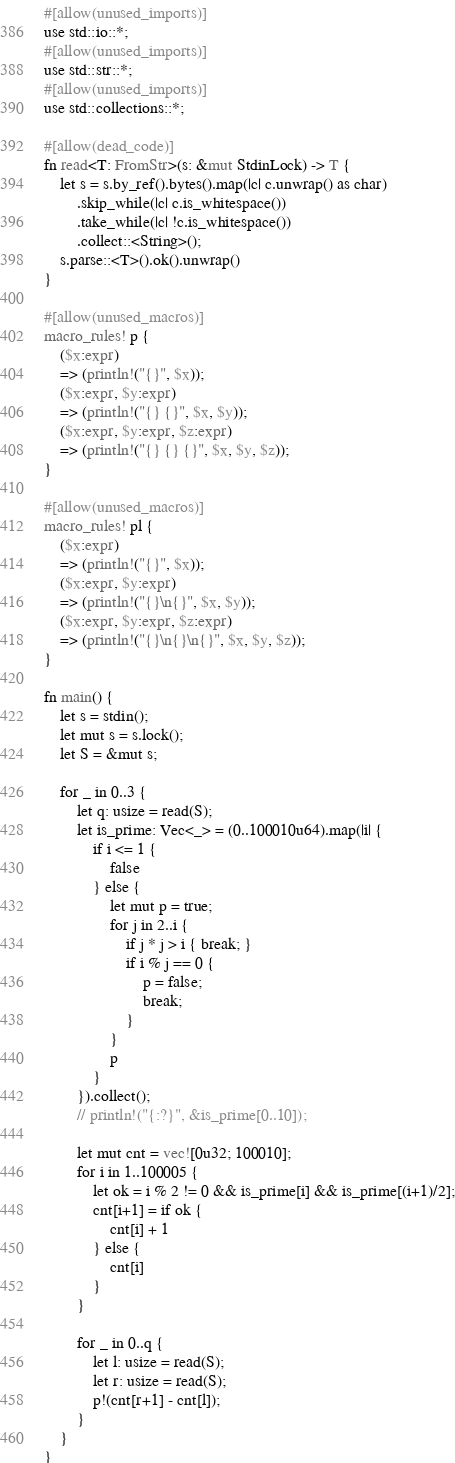<code> <loc_0><loc_0><loc_500><loc_500><_Rust_>#[allow(unused_imports)]
use std::io::*;
#[allow(unused_imports)]
use std::str::*;
#[allow(unused_imports)]
use std::collections::*;

#[allow(dead_code)]
fn read<T: FromStr>(s: &mut StdinLock) -> T {
    let s = s.by_ref().bytes().map(|c| c.unwrap() as char)
        .skip_while(|c| c.is_whitespace())
        .take_while(|c| !c.is_whitespace())
        .collect::<String>();
    s.parse::<T>().ok().unwrap()
}

#[allow(unused_macros)]
macro_rules! p {
    ($x:expr) 
    => (println!("{}", $x));
    ($x:expr, $y:expr)
    => (println!("{} {}", $x, $y));
    ($x:expr, $y:expr, $z:expr) 
    => (println!("{} {} {}", $x, $y, $z));
}

#[allow(unused_macros)]
macro_rules! pl {
    ($x:expr) 
    => (println!("{}", $x));
    ($x:expr, $y:expr)
    => (println!("{}\n{}", $x, $y));
    ($x:expr, $y:expr, $z:expr) 
    => (println!("{}\n{}\n{}", $x, $y, $z));
}

fn main() {
    let s = stdin();
    let mut s = s.lock();
    let S = &mut s;

    for _ in 0..3 {
        let q: usize = read(S);
        let is_prime: Vec<_> = (0..100010u64).map(|i| {
            if i <= 1 {
                false
            } else {
                let mut p = true;
                for j in 2..i {
                    if j * j > i { break; }
                    if i % j == 0 {
                        p = false;
                        break;
                    }
                }
                p
            }
        }).collect();
        // println!("{:?}", &is_prime[0..10]);

        let mut cnt = vec![0u32; 100010];
        for i in 1..100005 {
            let ok = i % 2 != 0 && is_prime[i] && is_prime[(i+1)/2];
            cnt[i+1] = if ok {
                cnt[i] + 1
            } else {
                cnt[i]
            }
        }

        for _ in 0..q {
            let l: usize = read(S);
            let r: usize = read(S);
            p!(cnt[r+1] - cnt[l]);
        }
    }
}</code> 